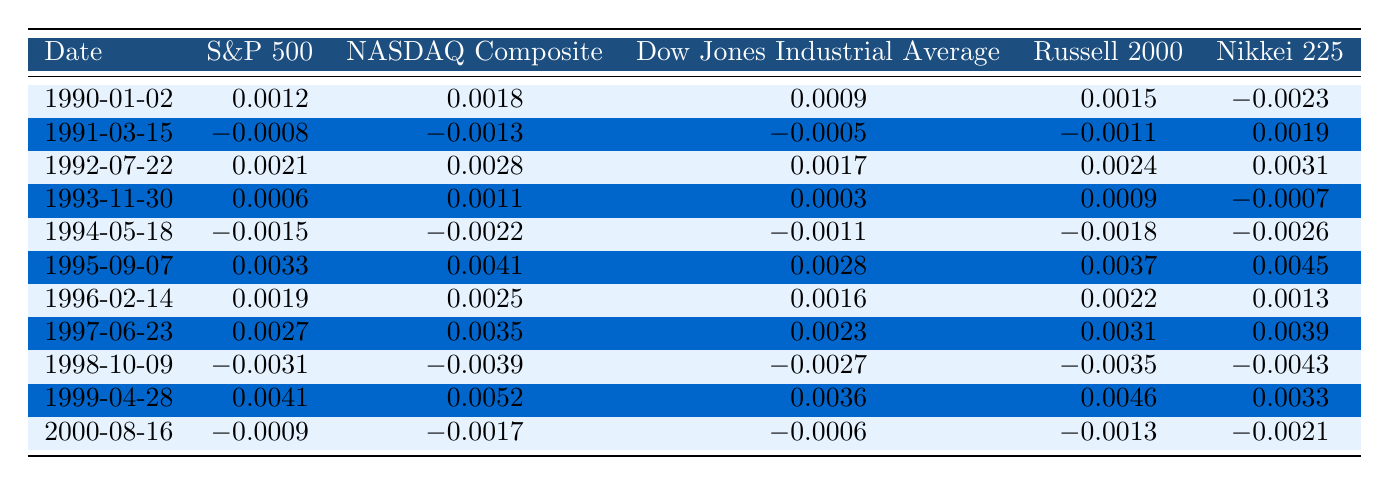What is the highest daily return for the S&P 500 from 1990 to 2000? The highest daily return for the S&P 500 in the table is 0.0041, which occurs on 1999-04-28.
Answer: 0.0041 What date had the lowest return for the Nikkei 225? The lowest return for the Nikkei 225 is -0.0043, which occurred on 1998-10-09.
Answer: 1998-10-09 What is the average daily return of the NASDAQ Composite over the recorded period? To find the average, we add all the NASDAQ Composite returns: (0.0018 - 0.0013 + 0.0028 + 0.0011 - 0.0022 + 0.0041 + 0.0025 + 0.0035 - 0.0039 + 0.0052 - 0.0017) = 0.0121, then divide by the number of returns (11): 0.0121 / 11 = 0.0011.
Answer: 0.0011 Did the Russell 2000 ever have a positive daily return in this dataset? Yes, the Russell 2000 had several positive returns, the highest being 0.0046 on 1999-04-28.
Answer: Yes What is the difference between the highest return of the Dow Jones Industrial Average and the lowest return in the same period? The highest return of the Dow Jones Industrial Average is 0.0036 on 1999-04-28 and the lowest is -0.0027 on 1998-10-09. The difference is 0.0036 - (-0.0027) = 0.0036 + 0.0027 = 0.0063.
Answer: 0.0063 What was the overall trend of the S&P 500 returns from 1990 to 2000? To assess the trend, we note the general movement of the values. By observing the table, we can see that the S&P 500 had more positive returns than negative returns over the period, especially in the mid to late '90s, indicating an upward trend.
Answer: Upward trend Which index had the most variability in daily returns? Variability can be assessed by comparing the spread between the highest and lowest returns. Analyzing the data, the NASDAQ Composite had the highest return (0.0052) and the lowest (-0.0039), providing a larger range compared to other indices, indicating the most variability.
Answer: NASDAQ Composite What was the lowest return recorded for the Dow Jones Industrial Average? The lowest return for the Dow Jones Industrial Average within the dataset is -0.0027, occurring on 1998-10-09.
Answer: -0.0027 What would have been the total gain if someone invested in the Nikkei 225 only on the dates provided? To find the total gain, add all the returns together: (-0.0023 + 0.0019 + 0.0031 - 0.0007 - 0.0026 + 0.0045 + 0.0013 + 0.0039 - 0.0043 + 0.0033 - 0.0021) = 0.0031.
Answer: 0.0031 On which date did all stock indices have negative returns? The only date with all negative returns is on 1998-10-09 where S&P 500, NASDAQ Composite, Dow Jones, Russell 2000, and Nikkei 225 all had negative values.
Answer: 1998-10-09 